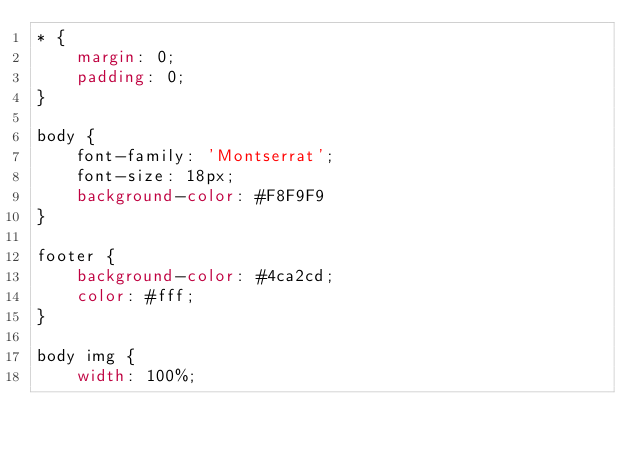<code> <loc_0><loc_0><loc_500><loc_500><_CSS_>* {
    margin: 0;
    padding: 0;
}

body {
    font-family: 'Montserrat';
    font-size: 18px;
    background-color: #F8F9F9
}

footer {
    background-color: #4ca2cd;
    color: #fff;
}

body img {
    width: 100%;</code> 